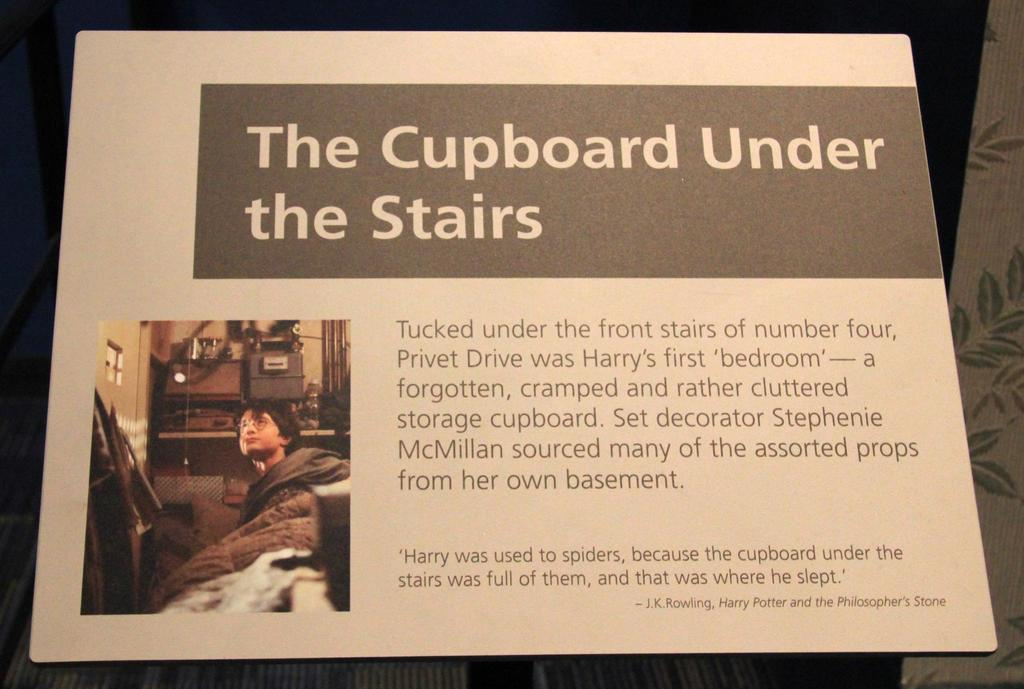What is the main object in the image? There is a board in the image. What is on the board? There is information on the board. Can you describe the person in the image? There is a person wearing spectacles in the image. What is the background of the image? There is a wall in the image. What else can be seen in the image? There are objects visible in the image. Can you tell me how many basketballs are visible in the image? There are no basketballs present in the image. Is there a window visible in the image? There is no window visible in the image. 